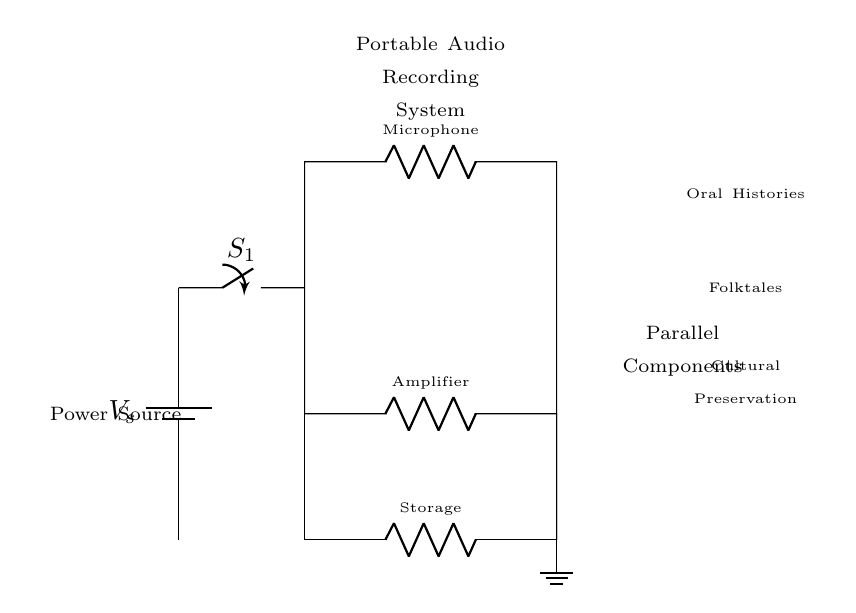What is the function of the microphone in this circuit? The microphone acts as R1, converting sound into an electrical signal, which is essential for audio recording.
Answer: microphone What are the components in parallel within the circuit? The components in parallel are the microphone (R1), the amplifier (R2), and the storage (R3). Each offers a different function which contributes to audio processing.
Answer: microphone, amplifier, storage How many parallel branches does the circuit have? The circuit has three parallel branches originating from the same point, providing multiple pathways for current to flow.
Answer: three What type of switch is used in this circuit? The circuit uses a standard switch (S1), allowing the user to turn the system on or off as needed for recording.
Answer: standard switch Why is a parallel circuit design chosen for this audio recording system? A parallel circuit design allows all components to operate simultaneously, ensuring that the microphone, amplifier, and storage systems can work together to effectively capture and process audio.
Answer: simultaneous operation 